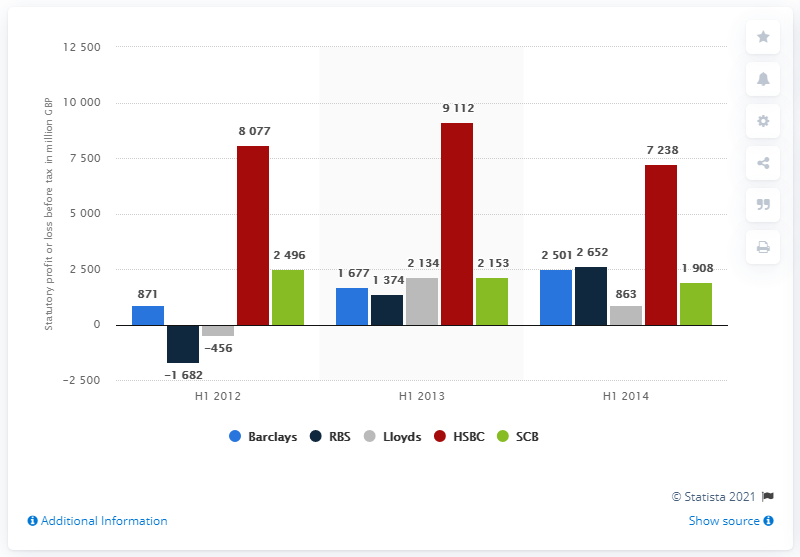Identify some key points in this picture. HSBC reported a statutory profit of 7,238 for the first half of 2014. 